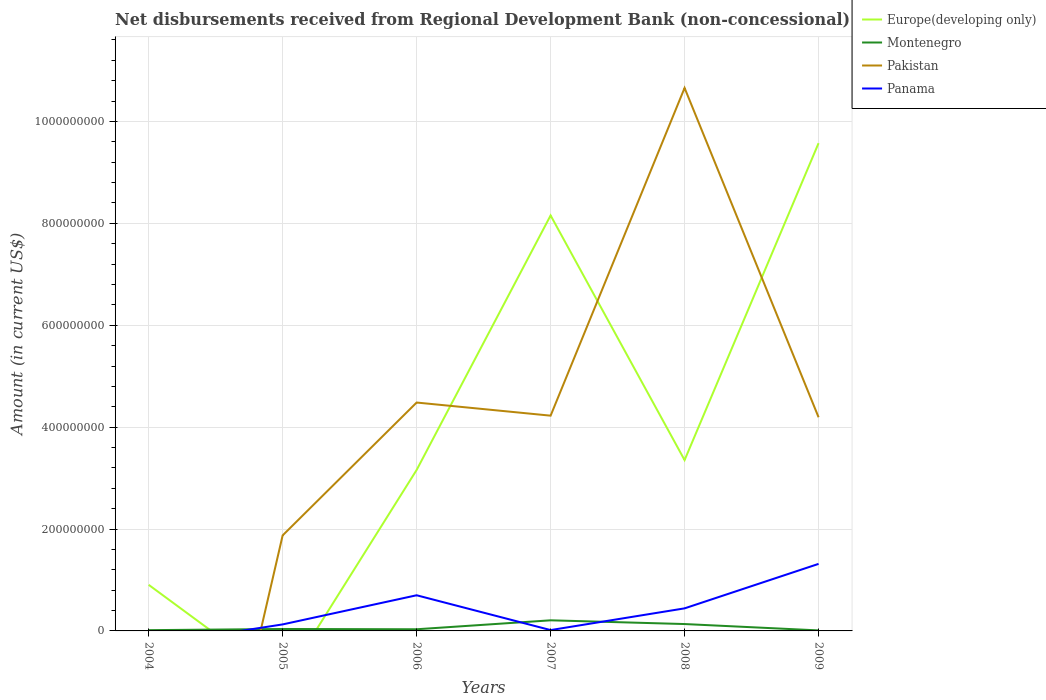How many different coloured lines are there?
Your answer should be compact. 4. Does the line corresponding to Pakistan intersect with the line corresponding to Europe(developing only)?
Your response must be concise. Yes. Is the number of lines equal to the number of legend labels?
Provide a short and direct response. No. What is the total amount of disbursements received from Regional Development Bank in Panama in the graph?
Your answer should be very brief. -3.15e+07. What is the difference between the highest and the second highest amount of disbursements received from Regional Development Bank in Europe(developing only)?
Give a very brief answer. 9.57e+08. Is the amount of disbursements received from Regional Development Bank in Pakistan strictly greater than the amount of disbursements received from Regional Development Bank in Europe(developing only) over the years?
Your answer should be compact. No. Are the values on the major ticks of Y-axis written in scientific E-notation?
Keep it short and to the point. No. Does the graph contain grids?
Offer a very short reply. Yes. Where does the legend appear in the graph?
Your response must be concise. Top right. What is the title of the graph?
Ensure brevity in your answer.  Net disbursements received from Regional Development Bank (non-concessional). What is the label or title of the X-axis?
Provide a short and direct response. Years. What is the Amount (in current US$) in Europe(developing only) in 2004?
Provide a succinct answer. 9.05e+07. What is the Amount (in current US$) in Montenegro in 2004?
Your answer should be compact. 1.50e+06. What is the Amount (in current US$) in Panama in 2004?
Your answer should be compact. 0. What is the Amount (in current US$) in Montenegro in 2005?
Make the answer very short. 3.80e+06. What is the Amount (in current US$) of Pakistan in 2005?
Give a very brief answer. 1.88e+08. What is the Amount (in current US$) of Panama in 2005?
Your answer should be compact. 1.28e+07. What is the Amount (in current US$) in Europe(developing only) in 2006?
Give a very brief answer. 3.16e+08. What is the Amount (in current US$) in Montenegro in 2006?
Offer a very short reply. 3.25e+06. What is the Amount (in current US$) in Pakistan in 2006?
Your answer should be very brief. 4.48e+08. What is the Amount (in current US$) of Panama in 2006?
Your response must be concise. 7.00e+07. What is the Amount (in current US$) in Europe(developing only) in 2007?
Offer a terse response. 8.16e+08. What is the Amount (in current US$) in Montenegro in 2007?
Offer a very short reply. 2.08e+07. What is the Amount (in current US$) of Pakistan in 2007?
Your response must be concise. 4.23e+08. What is the Amount (in current US$) in Panama in 2007?
Provide a succinct answer. 1.66e+06. What is the Amount (in current US$) of Europe(developing only) in 2008?
Your response must be concise. 3.35e+08. What is the Amount (in current US$) in Montenegro in 2008?
Ensure brevity in your answer.  1.35e+07. What is the Amount (in current US$) in Pakistan in 2008?
Your answer should be very brief. 1.07e+09. What is the Amount (in current US$) in Panama in 2008?
Offer a very short reply. 4.43e+07. What is the Amount (in current US$) in Europe(developing only) in 2009?
Provide a succinct answer. 9.57e+08. What is the Amount (in current US$) of Montenegro in 2009?
Keep it short and to the point. 1.02e+06. What is the Amount (in current US$) in Pakistan in 2009?
Your answer should be very brief. 4.19e+08. What is the Amount (in current US$) of Panama in 2009?
Give a very brief answer. 1.32e+08. Across all years, what is the maximum Amount (in current US$) in Europe(developing only)?
Ensure brevity in your answer.  9.57e+08. Across all years, what is the maximum Amount (in current US$) in Montenegro?
Your response must be concise. 2.08e+07. Across all years, what is the maximum Amount (in current US$) in Pakistan?
Offer a terse response. 1.07e+09. Across all years, what is the maximum Amount (in current US$) of Panama?
Offer a very short reply. 1.32e+08. Across all years, what is the minimum Amount (in current US$) of Europe(developing only)?
Offer a terse response. 0. Across all years, what is the minimum Amount (in current US$) of Montenegro?
Offer a very short reply. 1.02e+06. Across all years, what is the minimum Amount (in current US$) of Pakistan?
Your response must be concise. 0. What is the total Amount (in current US$) in Europe(developing only) in the graph?
Offer a very short reply. 2.51e+09. What is the total Amount (in current US$) in Montenegro in the graph?
Offer a very short reply. 4.39e+07. What is the total Amount (in current US$) of Pakistan in the graph?
Your answer should be very brief. 2.54e+09. What is the total Amount (in current US$) in Panama in the graph?
Offer a very short reply. 2.60e+08. What is the difference between the Amount (in current US$) of Montenegro in 2004 and that in 2005?
Your response must be concise. -2.29e+06. What is the difference between the Amount (in current US$) of Europe(developing only) in 2004 and that in 2006?
Provide a short and direct response. -2.25e+08. What is the difference between the Amount (in current US$) of Montenegro in 2004 and that in 2006?
Offer a very short reply. -1.74e+06. What is the difference between the Amount (in current US$) of Europe(developing only) in 2004 and that in 2007?
Your answer should be compact. -7.25e+08. What is the difference between the Amount (in current US$) in Montenegro in 2004 and that in 2007?
Offer a terse response. -1.93e+07. What is the difference between the Amount (in current US$) of Europe(developing only) in 2004 and that in 2008?
Ensure brevity in your answer.  -2.45e+08. What is the difference between the Amount (in current US$) in Montenegro in 2004 and that in 2008?
Provide a succinct answer. -1.20e+07. What is the difference between the Amount (in current US$) in Europe(developing only) in 2004 and that in 2009?
Ensure brevity in your answer.  -8.67e+08. What is the difference between the Amount (in current US$) in Montenegro in 2004 and that in 2009?
Provide a short and direct response. 4.88e+05. What is the difference between the Amount (in current US$) in Montenegro in 2005 and that in 2006?
Your response must be concise. 5.49e+05. What is the difference between the Amount (in current US$) in Pakistan in 2005 and that in 2006?
Your response must be concise. -2.61e+08. What is the difference between the Amount (in current US$) of Panama in 2005 and that in 2006?
Provide a succinct answer. -5.72e+07. What is the difference between the Amount (in current US$) of Montenegro in 2005 and that in 2007?
Ensure brevity in your answer.  -1.70e+07. What is the difference between the Amount (in current US$) in Pakistan in 2005 and that in 2007?
Ensure brevity in your answer.  -2.35e+08. What is the difference between the Amount (in current US$) in Panama in 2005 and that in 2007?
Ensure brevity in your answer.  1.11e+07. What is the difference between the Amount (in current US$) in Montenegro in 2005 and that in 2008?
Your answer should be very brief. -9.70e+06. What is the difference between the Amount (in current US$) of Pakistan in 2005 and that in 2008?
Make the answer very short. -8.78e+08. What is the difference between the Amount (in current US$) in Panama in 2005 and that in 2008?
Your response must be concise. -3.15e+07. What is the difference between the Amount (in current US$) of Montenegro in 2005 and that in 2009?
Offer a terse response. 2.78e+06. What is the difference between the Amount (in current US$) of Pakistan in 2005 and that in 2009?
Ensure brevity in your answer.  -2.32e+08. What is the difference between the Amount (in current US$) of Panama in 2005 and that in 2009?
Ensure brevity in your answer.  -1.19e+08. What is the difference between the Amount (in current US$) of Europe(developing only) in 2006 and that in 2007?
Provide a short and direct response. -5.00e+08. What is the difference between the Amount (in current US$) of Montenegro in 2006 and that in 2007?
Offer a terse response. -1.76e+07. What is the difference between the Amount (in current US$) of Pakistan in 2006 and that in 2007?
Your response must be concise. 2.58e+07. What is the difference between the Amount (in current US$) of Panama in 2006 and that in 2007?
Offer a terse response. 6.83e+07. What is the difference between the Amount (in current US$) in Europe(developing only) in 2006 and that in 2008?
Your answer should be very brief. -1.94e+07. What is the difference between the Amount (in current US$) in Montenegro in 2006 and that in 2008?
Keep it short and to the point. -1.02e+07. What is the difference between the Amount (in current US$) of Pakistan in 2006 and that in 2008?
Ensure brevity in your answer.  -6.18e+08. What is the difference between the Amount (in current US$) of Panama in 2006 and that in 2008?
Your answer should be compact. 2.57e+07. What is the difference between the Amount (in current US$) of Europe(developing only) in 2006 and that in 2009?
Your answer should be very brief. -6.41e+08. What is the difference between the Amount (in current US$) in Montenegro in 2006 and that in 2009?
Your answer should be very brief. 2.23e+06. What is the difference between the Amount (in current US$) of Pakistan in 2006 and that in 2009?
Provide a succinct answer. 2.89e+07. What is the difference between the Amount (in current US$) of Panama in 2006 and that in 2009?
Provide a succinct answer. -6.16e+07. What is the difference between the Amount (in current US$) of Europe(developing only) in 2007 and that in 2008?
Provide a short and direct response. 4.80e+08. What is the difference between the Amount (in current US$) of Montenegro in 2007 and that in 2008?
Your answer should be compact. 7.33e+06. What is the difference between the Amount (in current US$) of Pakistan in 2007 and that in 2008?
Keep it short and to the point. -6.43e+08. What is the difference between the Amount (in current US$) in Panama in 2007 and that in 2008?
Offer a very short reply. -4.26e+07. What is the difference between the Amount (in current US$) of Europe(developing only) in 2007 and that in 2009?
Offer a very short reply. -1.42e+08. What is the difference between the Amount (in current US$) in Montenegro in 2007 and that in 2009?
Your answer should be compact. 1.98e+07. What is the difference between the Amount (in current US$) of Pakistan in 2007 and that in 2009?
Offer a very short reply. 3.12e+06. What is the difference between the Amount (in current US$) of Panama in 2007 and that in 2009?
Keep it short and to the point. -1.30e+08. What is the difference between the Amount (in current US$) in Europe(developing only) in 2008 and that in 2009?
Your answer should be very brief. -6.22e+08. What is the difference between the Amount (in current US$) in Montenegro in 2008 and that in 2009?
Your answer should be very brief. 1.25e+07. What is the difference between the Amount (in current US$) in Pakistan in 2008 and that in 2009?
Provide a succinct answer. 6.46e+08. What is the difference between the Amount (in current US$) of Panama in 2008 and that in 2009?
Give a very brief answer. -8.73e+07. What is the difference between the Amount (in current US$) of Europe(developing only) in 2004 and the Amount (in current US$) of Montenegro in 2005?
Offer a terse response. 8.67e+07. What is the difference between the Amount (in current US$) of Europe(developing only) in 2004 and the Amount (in current US$) of Pakistan in 2005?
Your response must be concise. -9.70e+07. What is the difference between the Amount (in current US$) in Europe(developing only) in 2004 and the Amount (in current US$) in Panama in 2005?
Your response must be concise. 7.77e+07. What is the difference between the Amount (in current US$) in Montenegro in 2004 and the Amount (in current US$) in Pakistan in 2005?
Provide a succinct answer. -1.86e+08. What is the difference between the Amount (in current US$) in Montenegro in 2004 and the Amount (in current US$) in Panama in 2005?
Provide a short and direct response. -1.13e+07. What is the difference between the Amount (in current US$) of Europe(developing only) in 2004 and the Amount (in current US$) of Montenegro in 2006?
Your answer should be very brief. 8.72e+07. What is the difference between the Amount (in current US$) in Europe(developing only) in 2004 and the Amount (in current US$) in Pakistan in 2006?
Offer a very short reply. -3.58e+08. What is the difference between the Amount (in current US$) of Europe(developing only) in 2004 and the Amount (in current US$) of Panama in 2006?
Give a very brief answer. 2.05e+07. What is the difference between the Amount (in current US$) in Montenegro in 2004 and the Amount (in current US$) in Pakistan in 2006?
Provide a short and direct response. -4.47e+08. What is the difference between the Amount (in current US$) in Montenegro in 2004 and the Amount (in current US$) in Panama in 2006?
Make the answer very short. -6.85e+07. What is the difference between the Amount (in current US$) in Europe(developing only) in 2004 and the Amount (in current US$) in Montenegro in 2007?
Keep it short and to the point. 6.97e+07. What is the difference between the Amount (in current US$) in Europe(developing only) in 2004 and the Amount (in current US$) in Pakistan in 2007?
Make the answer very short. -3.32e+08. What is the difference between the Amount (in current US$) in Europe(developing only) in 2004 and the Amount (in current US$) in Panama in 2007?
Your answer should be very brief. 8.88e+07. What is the difference between the Amount (in current US$) in Montenegro in 2004 and the Amount (in current US$) in Pakistan in 2007?
Offer a very short reply. -4.21e+08. What is the difference between the Amount (in current US$) in Montenegro in 2004 and the Amount (in current US$) in Panama in 2007?
Offer a terse response. -1.51e+05. What is the difference between the Amount (in current US$) of Europe(developing only) in 2004 and the Amount (in current US$) of Montenegro in 2008?
Make the answer very short. 7.70e+07. What is the difference between the Amount (in current US$) in Europe(developing only) in 2004 and the Amount (in current US$) in Pakistan in 2008?
Provide a short and direct response. -9.75e+08. What is the difference between the Amount (in current US$) of Europe(developing only) in 2004 and the Amount (in current US$) of Panama in 2008?
Make the answer very short. 4.62e+07. What is the difference between the Amount (in current US$) of Montenegro in 2004 and the Amount (in current US$) of Pakistan in 2008?
Provide a succinct answer. -1.06e+09. What is the difference between the Amount (in current US$) in Montenegro in 2004 and the Amount (in current US$) in Panama in 2008?
Offer a very short reply. -4.28e+07. What is the difference between the Amount (in current US$) of Europe(developing only) in 2004 and the Amount (in current US$) of Montenegro in 2009?
Provide a succinct answer. 8.95e+07. What is the difference between the Amount (in current US$) in Europe(developing only) in 2004 and the Amount (in current US$) in Pakistan in 2009?
Give a very brief answer. -3.29e+08. What is the difference between the Amount (in current US$) in Europe(developing only) in 2004 and the Amount (in current US$) in Panama in 2009?
Offer a terse response. -4.11e+07. What is the difference between the Amount (in current US$) of Montenegro in 2004 and the Amount (in current US$) of Pakistan in 2009?
Keep it short and to the point. -4.18e+08. What is the difference between the Amount (in current US$) of Montenegro in 2004 and the Amount (in current US$) of Panama in 2009?
Your answer should be very brief. -1.30e+08. What is the difference between the Amount (in current US$) of Montenegro in 2005 and the Amount (in current US$) of Pakistan in 2006?
Offer a terse response. -4.44e+08. What is the difference between the Amount (in current US$) in Montenegro in 2005 and the Amount (in current US$) in Panama in 2006?
Keep it short and to the point. -6.62e+07. What is the difference between the Amount (in current US$) of Pakistan in 2005 and the Amount (in current US$) of Panama in 2006?
Make the answer very short. 1.18e+08. What is the difference between the Amount (in current US$) of Montenegro in 2005 and the Amount (in current US$) of Pakistan in 2007?
Offer a terse response. -4.19e+08. What is the difference between the Amount (in current US$) in Montenegro in 2005 and the Amount (in current US$) in Panama in 2007?
Make the answer very short. 2.14e+06. What is the difference between the Amount (in current US$) in Pakistan in 2005 and the Amount (in current US$) in Panama in 2007?
Keep it short and to the point. 1.86e+08. What is the difference between the Amount (in current US$) in Montenegro in 2005 and the Amount (in current US$) in Pakistan in 2008?
Your response must be concise. -1.06e+09. What is the difference between the Amount (in current US$) in Montenegro in 2005 and the Amount (in current US$) in Panama in 2008?
Your response must be concise. -4.05e+07. What is the difference between the Amount (in current US$) in Pakistan in 2005 and the Amount (in current US$) in Panama in 2008?
Provide a short and direct response. 1.43e+08. What is the difference between the Amount (in current US$) in Montenegro in 2005 and the Amount (in current US$) in Pakistan in 2009?
Provide a short and direct response. -4.16e+08. What is the difference between the Amount (in current US$) in Montenegro in 2005 and the Amount (in current US$) in Panama in 2009?
Keep it short and to the point. -1.28e+08. What is the difference between the Amount (in current US$) of Pakistan in 2005 and the Amount (in current US$) of Panama in 2009?
Offer a terse response. 5.60e+07. What is the difference between the Amount (in current US$) in Europe(developing only) in 2006 and the Amount (in current US$) in Montenegro in 2007?
Offer a very short reply. 2.95e+08. What is the difference between the Amount (in current US$) of Europe(developing only) in 2006 and the Amount (in current US$) of Pakistan in 2007?
Your answer should be compact. -1.07e+08. What is the difference between the Amount (in current US$) in Europe(developing only) in 2006 and the Amount (in current US$) in Panama in 2007?
Ensure brevity in your answer.  3.14e+08. What is the difference between the Amount (in current US$) of Montenegro in 2006 and the Amount (in current US$) of Pakistan in 2007?
Provide a short and direct response. -4.19e+08. What is the difference between the Amount (in current US$) of Montenegro in 2006 and the Amount (in current US$) of Panama in 2007?
Your answer should be very brief. 1.59e+06. What is the difference between the Amount (in current US$) of Pakistan in 2006 and the Amount (in current US$) of Panama in 2007?
Give a very brief answer. 4.47e+08. What is the difference between the Amount (in current US$) of Europe(developing only) in 2006 and the Amount (in current US$) of Montenegro in 2008?
Offer a terse response. 3.02e+08. What is the difference between the Amount (in current US$) in Europe(developing only) in 2006 and the Amount (in current US$) in Pakistan in 2008?
Make the answer very short. -7.50e+08. What is the difference between the Amount (in current US$) in Europe(developing only) in 2006 and the Amount (in current US$) in Panama in 2008?
Your answer should be compact. 2.72e+08. What is the difference between the Amount (in current US$) of Montenegro in 2006 and the Amount (in current US$) of Pakistan in 2008?
Offer a very short reply. -1.06e+09. What is the difference between the Amount (in current US$) in Montenegro in 2006 and the Amount (in current US$) in Panama in 2008?
Your response must be concise. -4.10e+07. What is the difference between the Amount (in current US$) of Pakistan in 2006 and the Amount (in current US$) of Panama in 2008?
Make the answer very short. 4.04e+08. What is the difference between the Amount (in current US$) in Europe(developing only) in 2006 and the Amount (in current US$) in Montenegro in 2009?
Provide a short and direct response. 3.15e+08. What is the difference between the Amount (in current US$) in Europe(developing only) in 2006 and the Amount (in current US$) in Pakistan in 2009?
Give a very brief answer. -1.03e+08. What is the difference between the Amount (in current US$) of Europe(developing only) in 2006 and the Amount (in current US$) of Panama in 2009?
Keep it short and to the point. 1.84e+08. What is the difference between the Amount (in current US$) of Montenegro in 2006 and the Amount (in current US$) of Pakistan in 2009?
Provide a succinct answer. -4.16e+08. What is the difference between the Amount (in current US$) in Montenegro in 2006 and the Amount (in current US$) in Panama in 2009?
Make the answer very short. -1.28e+08. What is the difference between the Amount (in current US$) of Pakistan in 2006 and the Amount (in current US$) of Panama in 2009?
Provide a succinct answer. 3.17e+08. What is the difference between the Amount (in current US$) in Europe(developing only) in 2007 and the Amount (in current US$) in Montenegro in 2008?
Your response must be concise. 8.02e+08. What is the difference between the Amount (in current US$) of Europe(developing only) in 2007 and the Amount (in current US$) of Pakistan in 2008?
Your answer should be compact. -2.50e+08. What is the difference between the Amount (in current US$) in Europe(developing only) in 2007 and the Amount (in current US$) in Panama in 2008?
Keep it short and to the point. 7.71e+08. What is the difference between the Amount (in current US$) in Montenegro in 2007 and the Amount (in current US$) in Pakistan in 2008?
Ensure brevity in your answer.  -1.04e+09. What is the difference between the Amount (in current US$) in Montenegro in 2007 and the Amount (in current US$) in Panama in 2008?
Provide a short and direct response. -2.35e+07. What is the difference between the Amount (in current US$) in Pakistan in 2007 and the Amount (in current US$) in Panama in 2008?
Your answer should be compact. 3.78e+08. What is the difference between the Amount (in current US$) of Europe(developing only) in 2007 and the Amount (in current US$) of Montenegro in 2009?
Offer a terse response. 8.15e+08. What is the difference between the Amount (in current US$) in Europe(developing only) in 2007 and the Amount (in current US$) in Pakistan in 2009?
Offer a very short reply. 3.96e+08. What is the difference between the Amount (in current US$) of Europe(developing only) in 2007 and the Amount (in current US$) of Panama in 2009?
Provide a short and direct response. 6.84e+08. What is the difference between the Amount (in current US$) of Montenegro in 2007 and the Amount (in current US$) of Pakistan in 2009?
Your response must be concise. -3.99e+08. What is the difference between the Amount (in current US$) of Montenegro in 2007 and the Amount (in current US$) of Panama in 2009?
Your response must be concise. -1.11e+08. What is the difference between the Amount (in current US$) of Pakistan in 2007 and the Amount (in current US$) of Panama in 2009?
Your answer should be very brief. 2.91e+08. What is the difference between the Amount (in current US$) of Europe(developing only) in 2008 and the Amount (in current US$) of Montenegro in 2009?
Offer a very short reply. 3.34e+08. What is the difference between the Amount (in current US$) of Europe(developing only) in 2008 and the Amount (in current US$) of Pakistan in 2009?
Your response must be concise. -8.41e+07. What is the difference between the Amount (in current US$) in Europe(developing only) in 2008 and the Amount (in current US$) in Panama in 2009?
Your answer should be compact. 2.04e+08. What is the difference between the Amount (in current US$) of Montenegro in 2008 and the Amount (in current US$) of Pakistan in 2009?
Your answer should be very brief. -4.06e+08. What is the difference between the Amount (in current US$) in Montenegro in 2008 and the Amount (in current US$) in Panama in 2009?
Offer a very short reply. -1.18e+08. What is the difference between the Amount (in current US$) in Pakistan in 2008 and the Amount (in current US$) in Panama in 2009?
Provide a short and direct response. 9.34e+08. What is the average Amount (in current US$) of Europe(developing only) per year?
Your answer should be very brief. 4.19e+08. What is the average Amount (in current US$) in Montenegro per year?
Ensure brevity in your answer.  7.31e+06. What is the average Amount (in current US$) in Pakistan per year?
Provide a succinct answer. 4.24e+08. What is the average Amount (in current US$) of Panama per year?
Provide a short and direct response. 4.34e+07. In the year 2004, what is the difference between the Amount (in current US$) in Europe(developing only) and Amount (in current US$) in Montenegro?
Keep it short and to the point. 8.90e+07. In the year 2005, what is the difference between the Amount (in current US$) of Montenegro and Amount (in current US$) of Pakistan?
Make the answer very short. -1.84e+08. In the year 2005, what is the difference between the Amount (in current US$) of Montenegro and Amount (in current US$) of Panama?
Provide a short and direct response. -8.99e+06. In the year 2005, what is the difference between the Amount (in current US$) in Pakistan and Amount (in current US$) in Panama?
Provide a succinct answer. 1.75e+08. In the year 2006, what is the difference between the Amount (in current US$) of Europe(developing only) and Amount (in current US$) of Montenegro?
Offer a very short reply. 3.13e+08. In the year 2006, what is the difference between the Amount (in current US$) of Europe(developing only) and Amount (in current US$) of Pakistan?
Your response must be concise. -1.32e+08. In the year 2006, what is the difference between the Amount (in current US$) in Europe(developing only) and Amount (in current US$) in Panama?
Offer a terse response. 2.46e+08. In the year 2006, what is the difference between the Amount (in current US$) in Montenegro and Amount (in current US$) in Pakistan?
Your answer should be compact. -4.45e+08. In the year 2006, what is the difference between the Amount (in current US$) of Montenegro and Amount (in current US$) of Panama?
Your answer should be compact. -6.67e+07. In the year 2006, what is the difference between the Amount (in current US$) of Pakistan and Amount (in current US$) of Panama?
Your response must be concise. 3.78e+08. In the year 2007, what is the difference between the Amount (in current US$) of Europe(developing only) and Amount (in current US$) of Montenegro?
Your answer should be very brief. 7.95e+08. In the year 2007, what is the difference between the Amount (in current US$) in Europe(developing only) and Amount (in current US$) in Pakistan?
Your answer should be compact. 3.93e+08. In the year 2007, what is the difference between the Amount (in current US$) in Europe(developing only) and Amount (in current US$) in Panama?
Give a very brief answer. 8.14e+08. In the year 2007, what is the difference between the Amount (in current US$) in Montenegro and Amount (in current US$) in Pakistan?
Offer a terse response. -4.02e+08. In the year 2007, what is the difference between the Amount (in current US$) in Montenegro and Amount (in current US$) in Panama?
Your response must be concise. 1.92e+07. In the year 2007, what is the difference between the Amount (in current US$) of Pakistan and Amount (in current US$) of Panama?
Give a very brief answer. 4.21e+08. In the year 2008, what is the difference between the Amount (in current US$) in Europe(developing only) and Amount (in current US$) in Montenegro?
Offer a terse response. 3.22e+08. In the year 2008, what is the difference between the Amount (in current US$) in Europe(developing only) and Amount (in current US$) in Pakistan?
Keep it short and to the point. -7.31e+08. In the year 2008, what is the difference between the Amount (in current US$) of Europe(developing only) and Amount (in current US$) of Panama?
Make the answer very short. 2.91e+08. In the year 2008, what is the difference between the Amount (in current US$) in Montenegro and Amount (in current US$) in Pakistan?
Offer a very short reply. -1.05e+09. In the year 2008, what is the difference between the Amount (in current US$) in Montenegro and Amount (in current US$) in Panama?
Provide a short and direct response. -3.08e+07. In the year 2008, what is the difference between the Amount (in current US$) of Pakistan and Amount (in current US$) of Panama?
Ensure brevity in your answer.  1.02e+09. In the year 2009, what is the difference between the Amount (in current US$) in Europe(developing only) and Amount (in current US$) in Montenegro?
Give a very brief answer. 9.56e+08. In the year 2009, what is the difference between the Amount (in current US$) in Europe(developing only) and Amount (in current US$) in Pakistan?
Give a very brief answer. 5.38e+08. In the year 2009, what is the difference between the Amount (in current US$) of Europe(developing only) and Amount (in current US$) of Panama?
Your answer should be very brief. 8.26e+08. In the year 2009, what is the difference between the Amount (in current US$) of Montenegro and Amount (in current US$) of Pakistan?
Provide a short and direct response. -4.18e+08. In the year 2009, what is the difference between the Amount (in current US$) of Montenegro and Amount (in current US$) of Panama?
Provide a short and direct response. -1.31e+08. In the year 2009, what is the difference between the Amount (in current US$) of Pakistan and Amount (in current US$) of Panama?
Make the answer very short. 2.88e+08. What is the ratio of the Amount (in current US$) of Montenegro in 2004 to that in 2005?
Keep it short and to the point. 0.4. What is the ratio of the Amount (in current US$) in Europe(developing only) in 2004 to that in 2006?
Keep it short and to the point. 0.29. What is the ratio of the Amount (in current US$) of Montenegro in 2004 to that in 2006?
Your response must be concise. 0.46. What is the ratio of the Amount (in current US$) of Europe(developing only) in 2004 to that in 2007?
Provide a short and direct response. 0.11. What is the ratio of the Amount (in current US$) in Montenegro in 2004 to that in 2007?
Make the answer very short. 0.07. What is the ratio of the Amount (in current US$) in Europe(developing only) in 2004 to that in 2008?
Your response must be concise. 0.27. What is the ratio of the Amount (in current US$) in Montenegro in 2004 to that in 2008?
Your answer should be compact. 0.11. What is the ratio of the Amount (in current US$) in Europe(developing only) in 2004 to that in 2009?
Ensure brevity in your answer.  0.09. What is the ratio of the Amount (in current US$) in Montenegro in 2004 to that in 2009?
Make the answer very short. 1.48. What is the ratio of the Amount (in current US$) in Montenegro in 2005 to that in 2006?
Ensure brevity in your answer.  1.17. What is the ratio of the Amount (in current US$) of Pakistan in 2005 to that in 2006?
Provide a short and direct response. 0.42. What is the ratio of the Amount (in current US$) of Panama in 2005 to that in 2006?
Keep it short and to the point. 0.18. What is the ratio of the Amount (in current US$) in Montenegro in 2005 to that in 2007?
Keep it short and to the point. 0.18. What is the ratio of the Amount (in current US$) of Pakistan in 2005 to that in 2007?
Ensure brevity in your answer.  0.44. What is the ratio of the Amount (in current US$) in Panama in 2005 to that in 2007?
Provide a short and direct response. 7.72. What is the ratio of the Amount (in current US$) in Montenegro in 2005 to that in 2008?
Provide a short and direct response. 0.28. What is the ratio of the Amount (in current US$) of Pakistan in 2005 to that in 2008?
Make the answer very short. 0.18. What is the ratio of the Amount (in current US$) in Panama in 2005 to that in 2008?
Provide a short and direct response. 0.29. What is the ratio of the Amount (in current US$) in Montenegro in 2005 to that in 2009?
Give a very brief answer. 3.74. What is the ratio of the Amount (in current US$) of Pakistan in 2005 to that in 2009?
Your response must be concise. 0.45. What is the ratio of the Amount (in current US$) of Panama in 2005 to that in 2009?
Provide a succinct answer. 0.1. What is the ratio of the Amount (in current US$) of Europe(developing only) in 2006 to that in 2007?
Ensure brevity in your answer.  0.39. What is the ratio of the Amount (in current US$) of Montenegro in 2006 to that in 2007?
Keep it short and to the point. 0.16. What is the ratio of the Amount (in current US$) of Pakistan in 2006 to that in 2007?
Make the answer very short. 1.06. What is the ratio of the Amount (in current US$) of Panama in 2006 to that in 2007?
Your answer should be very brief. 42.29. What is the ratio of the Amount (in current US$) of Europe(developing only) in 2006 to that in 2008?
Make the answer very short. 0.94. What is the ratio of the Amount (in current US$) of Montenegro in 2006 to that in 2008?
Give a very brief answer. 0.24. What is the ratio of the Amount (in current US$) in Pakistan in 2006 to that in 2008?
Offer a terse response. 0.42. What is the ratio of the Amount (in current US$) in Panama in 2006 to that in 2008?
Offer a very short reply. 1.58. What is the ratio of the Amount (in current US$) of Europe(developing only) in 2006 to that in 2009?
Provide a succinct answer. 0.33. What is the ratio of the Amount (in current US$) in Montenegro in 2006 to that in 2009?
Provide a short and direct response. 3.19. What is the ratio of the Amount (in current US$) in Pakistan in 2006 to that in 2009?
Ensure brevity in your answer.  1.07. What is the ratio of the Amount (in current US$) in Panama in 2006 to that in 2009?
Offer a very short reply. 0.53. What is the ratio of the Amount (in current US$) in Europe(developing only) in 2007 to that in 2008?
Offer a terse response. 2.43. What is the ratio of the Amount (in current US$) in Montenegro in 2007 to that in 2008?
Provide a short and direct response. 1.54. What is the ratio of the Amount (in current US$) in Pakistan in 2007 to that in 2008?
Make the answer very short. 0.4. What is the ratio of the Amount (in current US$) of Panama in 2007 to that in 2008?
Make the answer very short. 0.04. What is the ratio of the Amount (in current US$) in Europe(developing only) in 2007 to that in 2009?
Your response must be concise. 0.85. What is the ratio of the Amount (in current US$) in Montenegro in 2007 to that in 2009?
Provide a succinct answer. 20.49. What is the ratio of the Amount (in current US$) in Pakistan in 2007 to that in 2009?
Provide a succinct answer. 1.01. What is the ratio of the Amount (in current US$) of Panama in 2007 to that in 2009?
Make the answer very short. 0.01. What is the ratio of the Amount (in current US$) of Europe(developing only) in 2008 to that in 2009?
Offer a terse response. 0.35. What is the ratio of the Amount (in current US$) of Montenegro in 2008 to that in 2009?
Provide a short and direct response. 13.28. What is the ratio of the Amount (in current US$) in Pakistan in 2008 to that in 2009?
Your answer should be compact. 2.54. What is the ratio of the Amount (in current US$) of Panama in 2008 to that in 2009?
Your response must be concise. 0.34. What is the difference between the highest and the second highest Amount (in current US$) in Europe(developing only)?
Ensure brevity in your answer.  1.42e+08. What is the difference between the highest and the second highest Amount (in current US$) in Montenegro?
Provide a succinct answer. 7.33e+06. What is the difference between the highest and the second highest Amount (in current US$) of Pakistan?
Provide a succinct answer. 6.18e+08. What is the difference between the highest and the second highest Amount (in current US$) in Panama?
Offer a terse response. 6.16e+07. What is the difference between the highest and the lowest Amount (in current US$) in Europe(developing only)?
Your response must be concise. 9.57e+08. What is the difference between the highest and the lowest Amount (in current US$) in Montenegro?
Provide a succinct answer. 1.98e+07. What is the difference between the highest and the lowest Amount (in current US$) of Pakistan?
Your response must be concise. 1.07e+09. What is the difference between the highest and the lowest Amount (in current US$) in Panama?
Your answer should be very brief. 1.32e+08. 